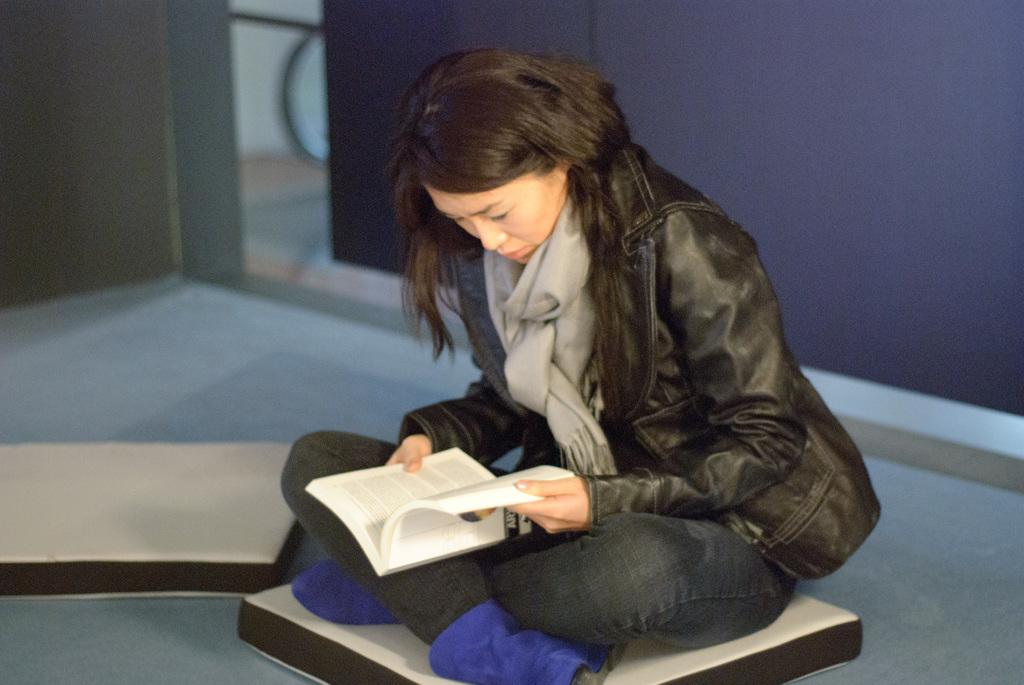Who is present in the image? There is a woman in the image. What is the woman wearing? The woman is wearing clothes and shoes. What is the woman doing in the image? The woman is sitting and holding a book in her hand. What can be seen beneath the woman in the image? There is a floor visible in the image. What is visible behind the woman in the image? There is a wall visible in the image. How would you describe the background of the image? The background is blurred. What sound can be heard coming from the book in the image? There is no sound coming from the book in the image; it is a static object. 